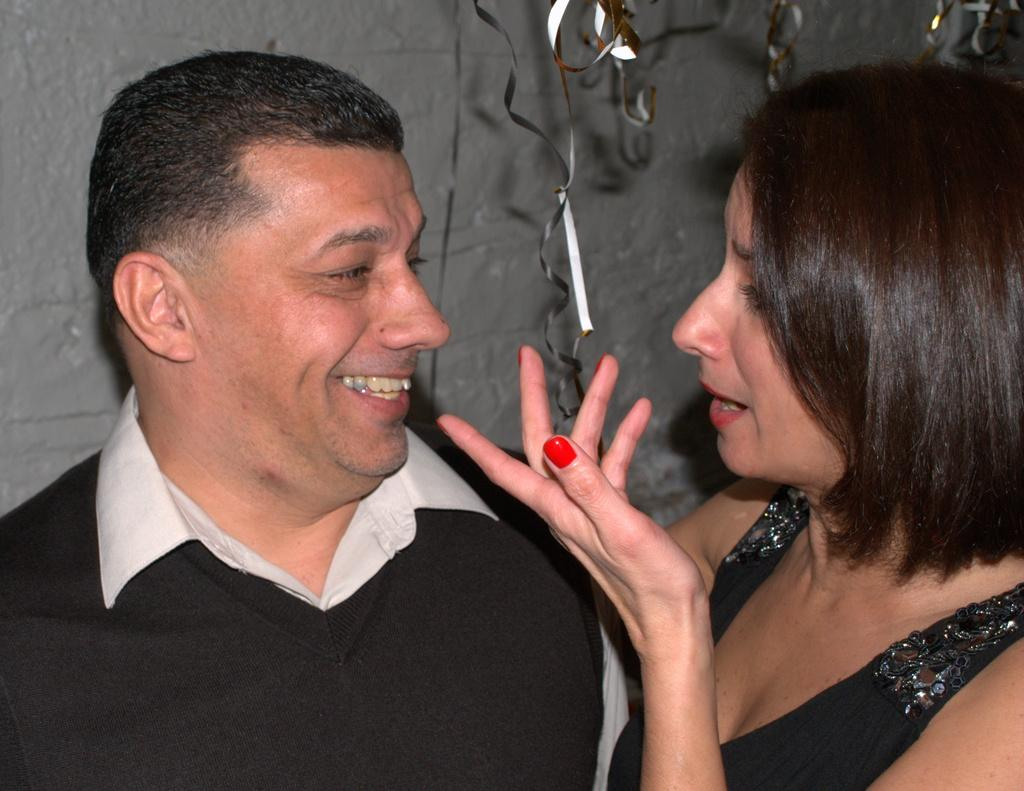Who is present in the image? There is a couple in the image. What is the man's facial expression? The man is smiling. What color are the clothes worn by both the man and woman? Both the man and woman are wearing black color dresses. What can be seen in the background of the image? There is a wall in the background of the image. What type of soap is the couple using in the image? There is no soap present in the image; it features a couple smiling and wearing black dresses. How many matches are visible in the image? There are no matches present in the image. 